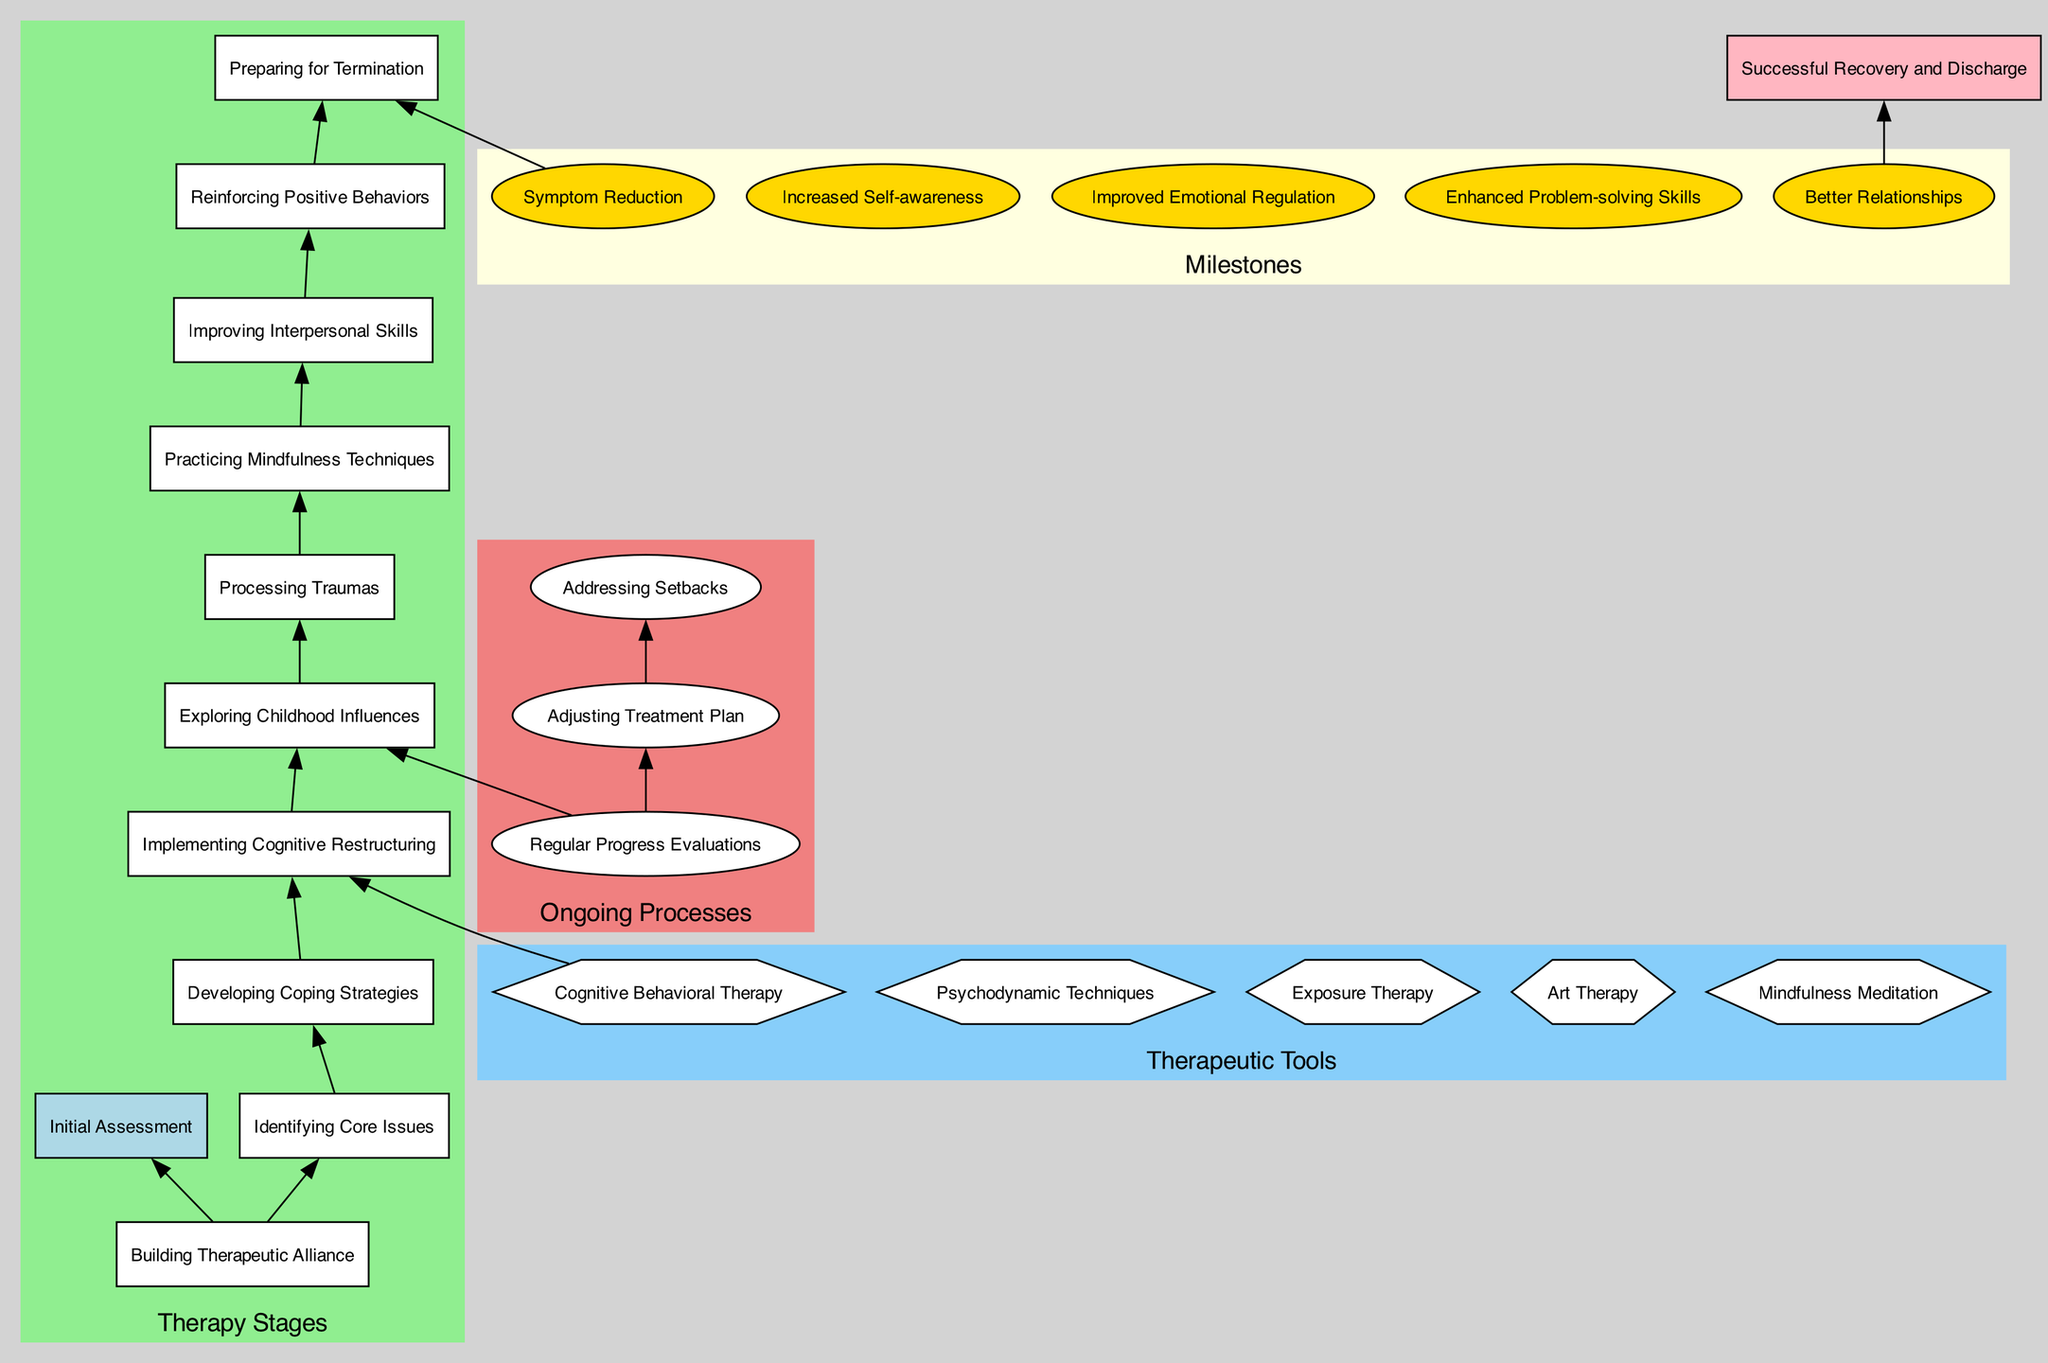What is the starting point of the therapy journey? The starting point is shown as the first node in the diagram, labeled 'Initial Assessment'. This is the entry point of the patient's journey through therapy.
Answer: Initial Assessment How many therapy stages are there in total? Counting the nodes labeled under the 'Therapy Stages' cluster, we find there are 10 stages including 'Initial Assessment'. Thus, the total is 10.
Answer: 10 What is the last milestone in the therapeutic journey? Referring to the milestones listed in the diagram, the last milestone is 'Better Relationships', which is the final point before reaching the end node.
Answer: Better Relationships Which stage immediately follows 'Building Therapeutic Alliance'? The stage immediately following 'Building Therapeutic Alliance' is identified by checking the connection to the next node, which is 'Identifying Core Issues'.
Answer: Identifying Core Issues What ongoing process follows 'Regular Progress Evaluations'? By analyzing the connections in the ongoing processes section, we see that 'Adjusting Treatment Plan' directly follows 'Regular Progress Evaluations'.
Answer: Adjusting Treatment Plan How many therapeutic tools are mentioned in the diagram? The tools are listed in a separate cluster, and upon counting them, we find there are 5 therapeutic tools identified.
Answer: 5 What therapy stage involves 'Practicing Mindfulness Techniques'? Looking through the stages sequentially, 'Practicing Mindfulness Techniques' is identified as the 8th stage in the flow.
Answer: Practicing Mindfulness Techniques What is the end point of the therapy process? The endpoint is clearly labeled in the diagram as 'Successful Recovery and Discharge', indicating the conclusion of the therapy journey.
Answer: Successful Recovery and Discharge Which milestone is achieved before termination? The milestone preceding 'Preparation for Termination' is 'Improved Emotional Regulation', indicating progress is made before this step.
Answer: Improved Emotional Regulation 